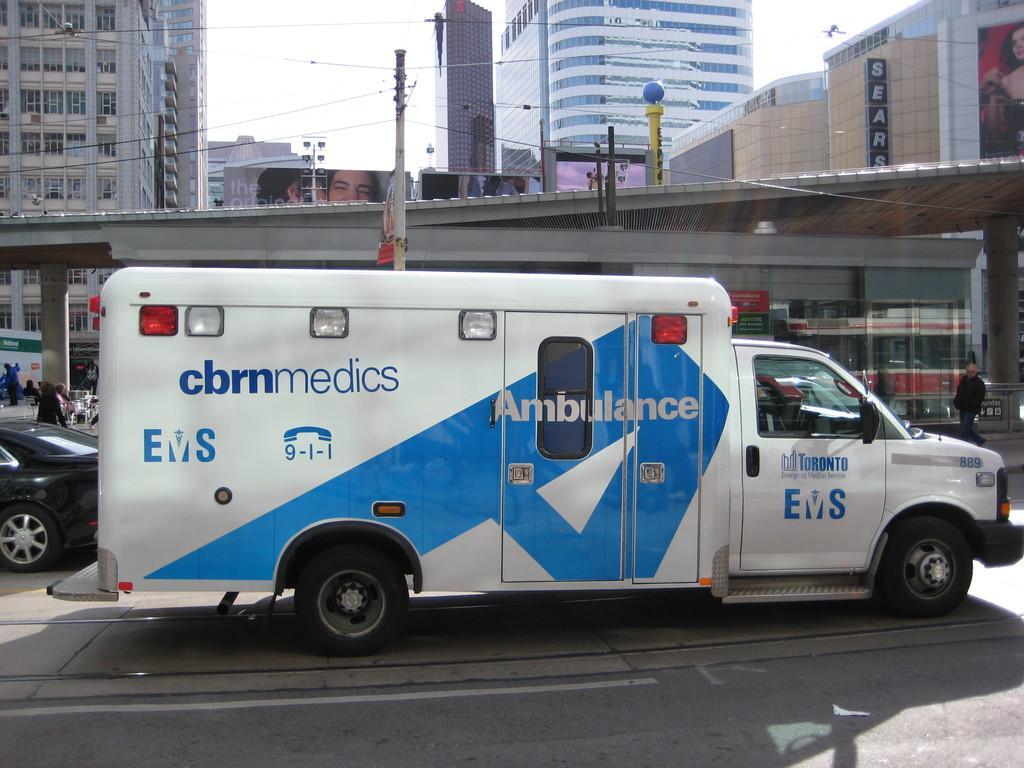In one or two sentences, can you explain what this image depicts? In this image I can see in the middle there is an ambulance, on the right side there is a person. On the left side there is a car in black color, in the middle it looks like a bridge. In the background there are buildings, at the top there is the sky. 